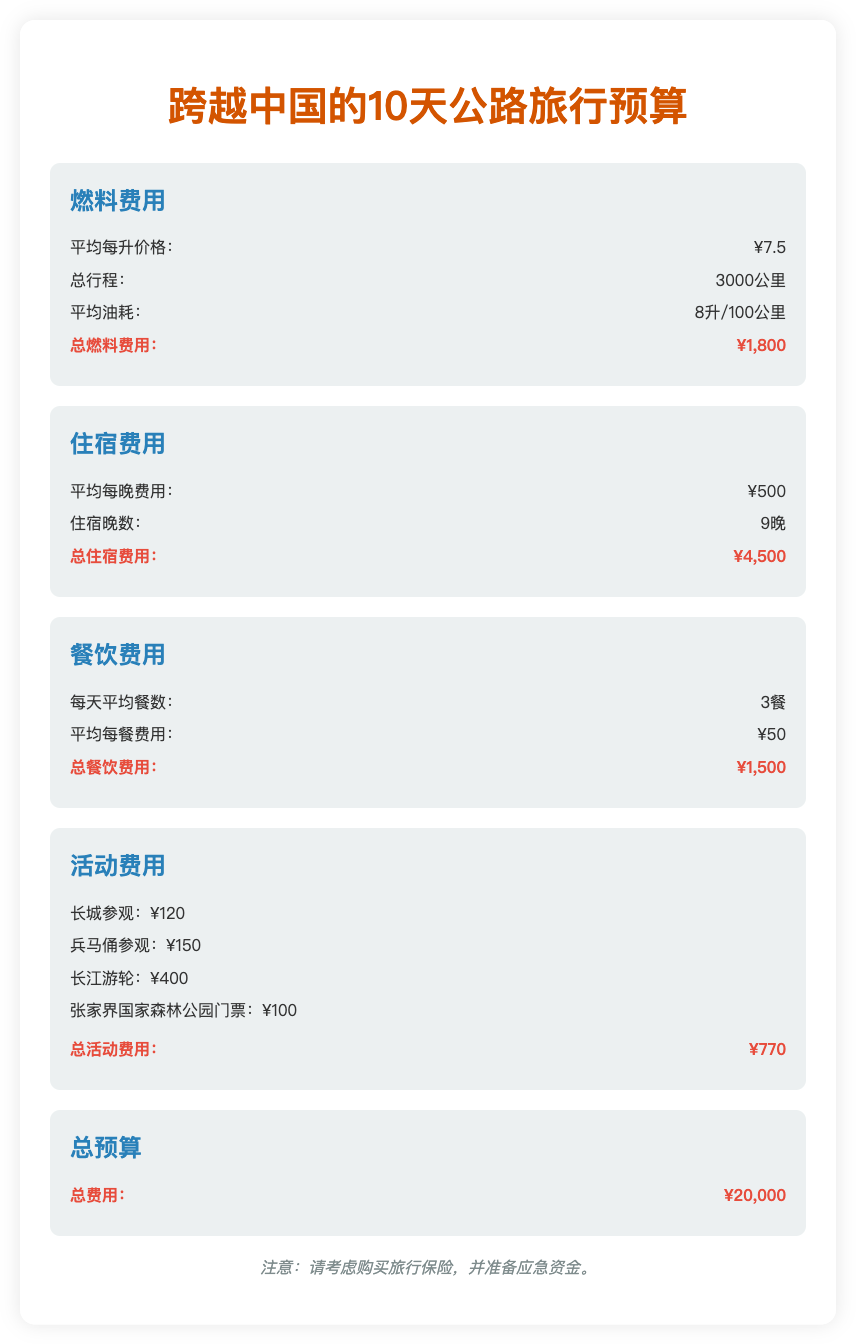What is the total fuel cost? The total fuel cost is listed under the fuel expenses section, which totals ¥1,800.
Answer: ¥1,800 How many days is the trip planned for? The trip duration is indicated in the title and throughout the document as a 10-day trip.
Answer: 10天 What is the average accommodation cost per night? The average accommodation cost per night is stated in the accommodations section, which is ¥500.
Answer: ¥500 What is the total cost for activities? The total cost for activities is calculated at the end of the activities section, which sums up to ¥770.
Answer: ¥770 How many nights will accommodations be needed? The document indicates that accommodations will be needed for 9 nights during the trip.
Answer: 9晚 What is the average number of meals per day? The average number of meals per day is noted in the food expenses section, which states 3 meals.
Answer: 3餐 What is the overall budget for the trip? The overall budget, found in the total budget section, indicates that the total expenses for the trip is ¥20,000.
Answer: ¥20,000 What is the average fuel price per liter? The average fuel price per liter is specified in the fuel expenses section as ¥7.5.
Answer: ¥7.5 How much is the ticket for the Great Wall visit? The ticket price for visiting the Great Wall is mentioned in the activities list as ¥120.
Answer: ¥120 